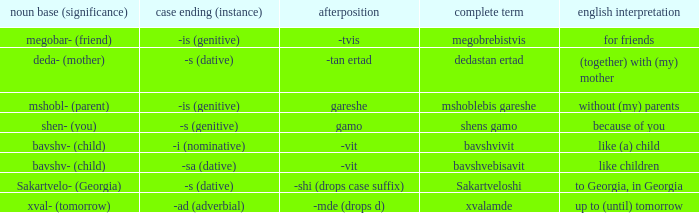What is Postposition, when Noun Root (Meaning) is "mshobl- (parent)"? Gareshe. 